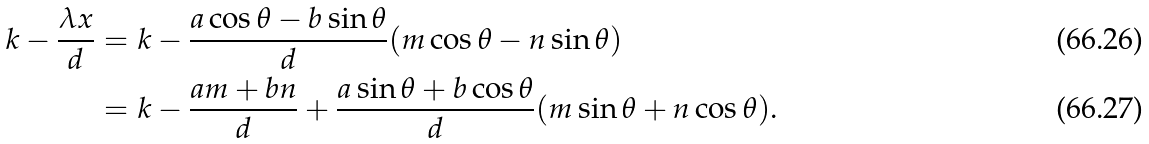<formula> <loc_0><loc_0><loc_500><loc_500>k - \frac { \lambda x } { d } & = k - \frac { a \cos \theta - b \sin \theta } { d } ( m \cos \theta - n \sin \theta ) \\ & = k - \frac { a m + b n } { d } + \frac { a \sin \theta + b \cos \theta } { d } ( m \sin \theta + n \cos \theta ) .</formula> 